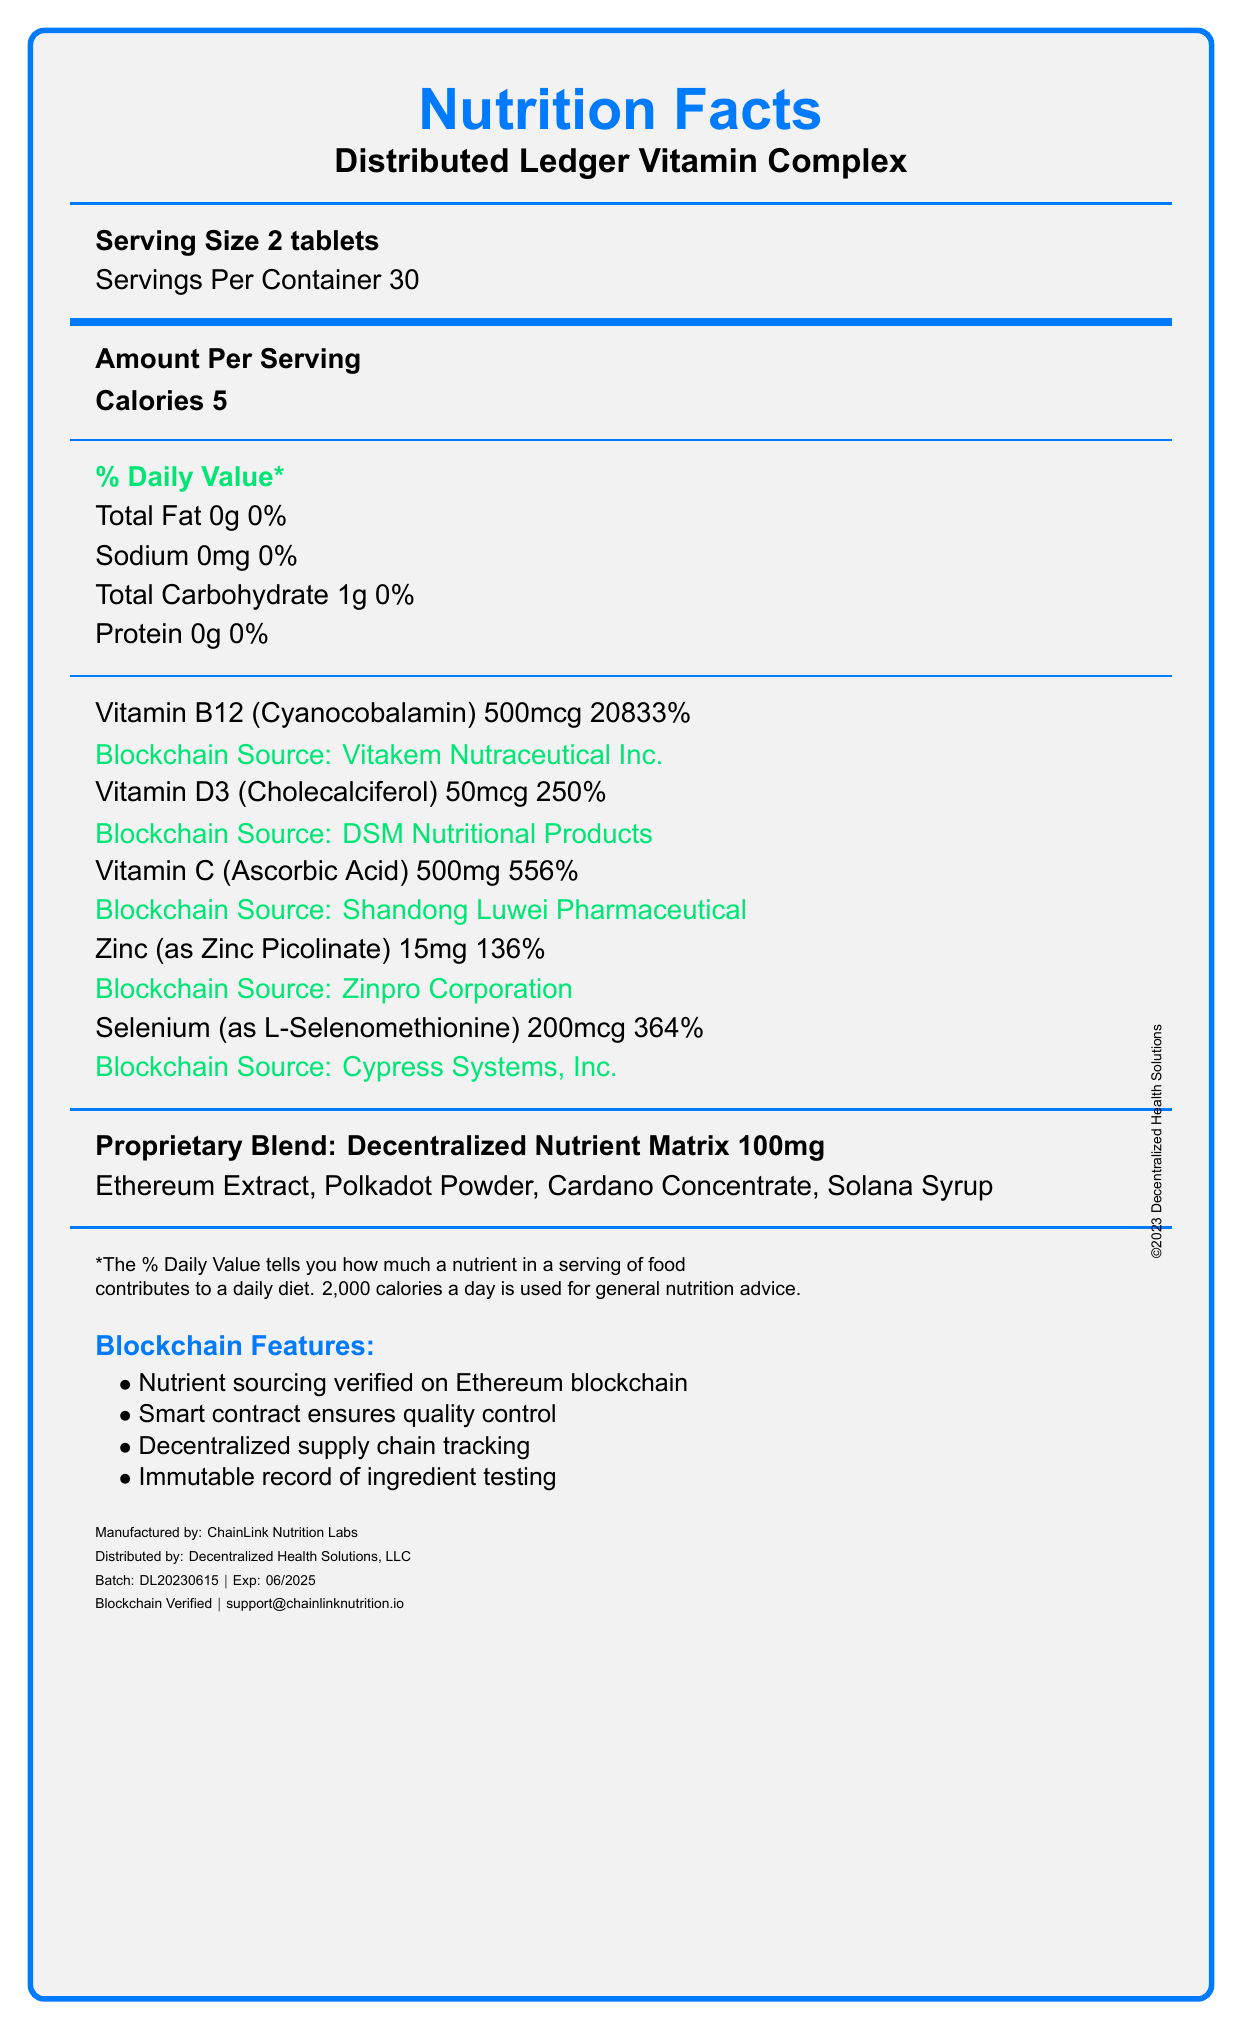What is the recommended serving size for Distributed Ledger Vitamin Complex? The document specifies "Serving Size 2 tablets" near the top of the nutrition facts.
Answer: 2 tablets How much Vitamin B12 does one serving contain? The "Vitamin B12 (Cyanocobalamin)" amount is listed as 500 mcg.
Answer: 500 mcg Who is the manufacturer of the product? The "Manufactured by" information is at the bottom of the document, stating ChainLink Nutrition Labs.
Answer: ChainLink Nutrition Labs What is the suggested use for this supplement? The "Suggested Use" section indicates to take 2 tablets daily or as directed.
Answer: Take 2 tablets daily with food or as directed by your blockchain healthcare professional What blockchain platform is used for nutrient sourcing verification? The "Blockchain Features" section mentions nutrient sourcing verified on the Ethereum blockchain.
Answer: Ethereum blockchain Which of the following vitamins has the highest daily value percentage? a. Vitamin B12 b. Vitamin D3 c. Vitamin C d. Zinc The daily value percentages are: Vitamin B12 (20833%), Vitamin D3 (250%), Vitamin C (556%), and Zinc (136%). Vitamin B12 has the highest daily value.
Answer: a. Vitamin B12 What is the total number of calories per serving? a. 1 b. 5 c. 10 d. 0 The "Calories" per serving is specified as 5.
Answer: b. 5 Is selenium one of the minerals included in the supplement? Selenium is listed with an amount of 200 mcg and 364% daily value.
Answer: Yes Summarize the main idea of the document. The main focus is on the nutrient content and the integration of blockchain technology for sourcing and quality control verification.
Answer: The document provides the nutrition facts for the Distributed Ledger Vitamin Complex, including serving size, vitamin and mineral content per serving, and blockchain features for nutrient sourcing verification. It also includes usage instructions, warning labels, manufacturer details, and other relevant product information. How many servings are there per container of the Distributed Ledger Vitamin Complex? The "Servings Per Container" is listed as 30 near the top of the nutrition facts.
Answer: 30 What are the ingredients in the proprietary blend called "Decentralized Nutrient Matrix"? The "Proprietary Blend" section lists these ingredients specifically.
Answer: Ethereum Extract, Polkadot Powder, Cardano Concentrate, Solana Syrup What is the batch number for this product? The batch number is provided at the bottom of the document under "Batch".
Answer: DL20230615 Does the document mention if the product is free from allergens? The document does not mention that the product is allergen-free; it instead states that it is manufactured in a facility that processes soy, tree nuts, and wheat.
Answer: No 